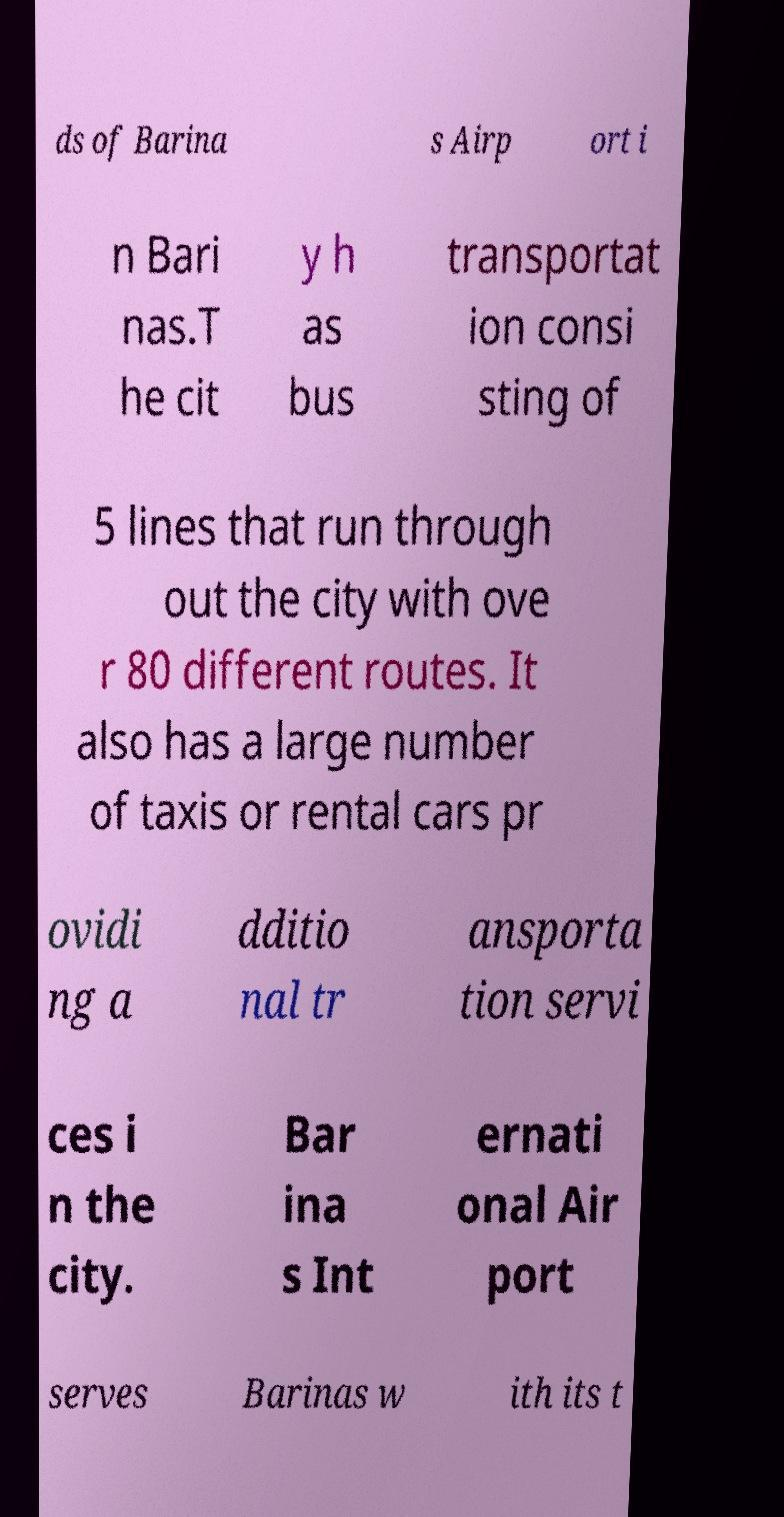For documentation purposes, I need the text within this image transcribed. Could you provide that? ds of Barina s Airp ort i n Bari nas.T he cit y h as bus transportat ion consi sting of 5 lines that run through out the city with ove r 80 different routes. It also has a large number of taxis or rental cars pr ovidi ng a dditio nal tr ansporta tion servi ces i n the city. Bar ina s Int ernati onal Air port serves Barinas w ith its t 